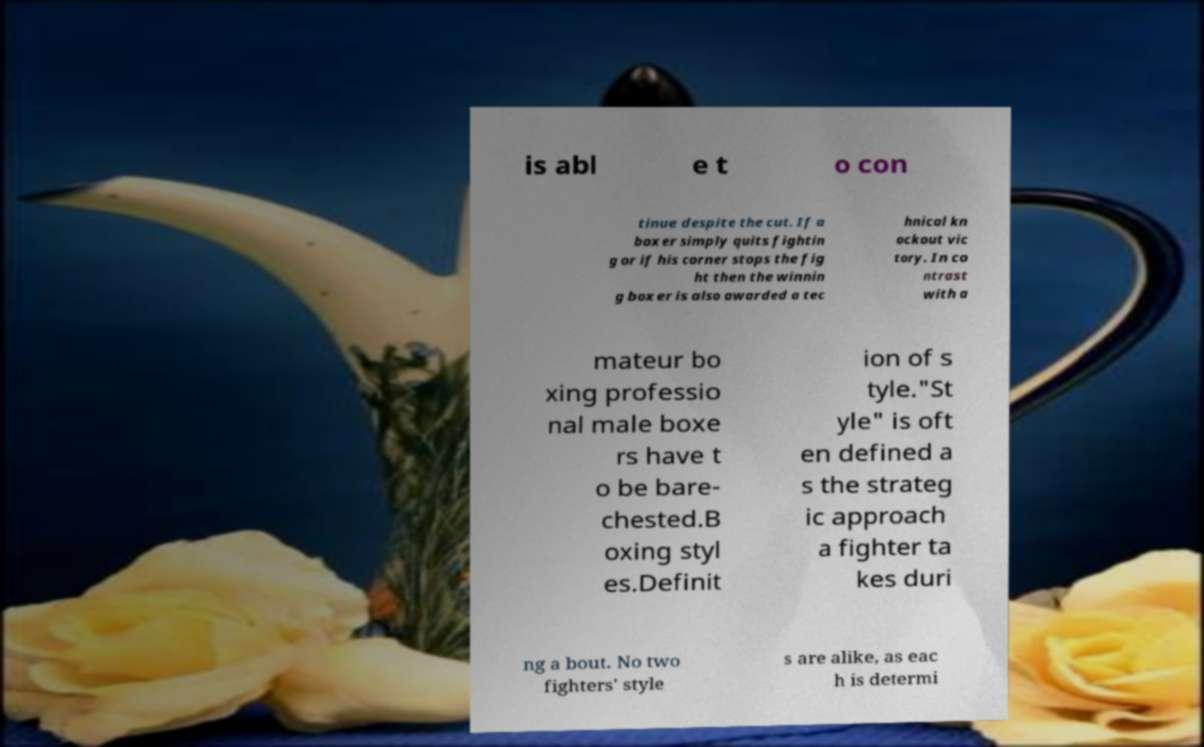What messages or text are displayed in this image? I need them in a readable, typed format. is abl e t o con tinue despite the cut. If a boxer simply quits fightin g or if his corner stops the fig ht then the winnin g boxer is also awarded a tec hnical kn ockout vic tory. In co ntrast with a mateur bo xing professio nal male boxe rs have t o be bare- chested.B oxing styl es.Definit ion of s tyle."St yle" is oft en defined a s the strateg ic approach a fighter ta kes duri ng a bout. No two fighters' style s are alike, as eac h is determi 